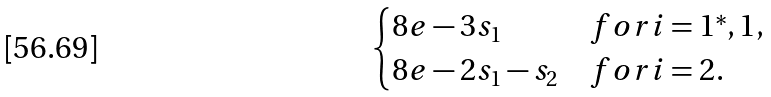Convert formula to latex. <formula><loc_0><loc_0><loc_500><loc_500>\begin{cases} 8 e - 3 s _ { 1 } & f o r i = 1 ^ { * } , 1 , \\ 8 e - 2 s _ { 1 } - s _ { 2 } & f o r i = 2 . \end{cases}</formula> 